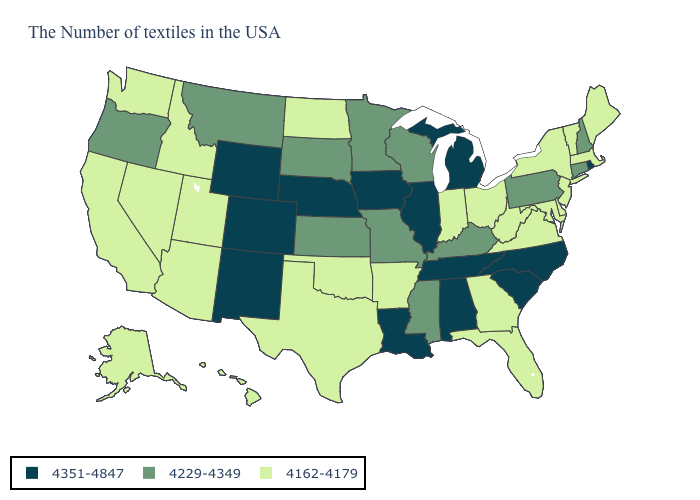Does Florida have the highest value in the South?
Be succinct. No. What is the value of Alaska?
Quick response, please. 4162-4179. Name the states that have a value in the range 4162-4179?
Keep it brief. Maine, Massachusetts, Vermont, New York, New Jersey, Delaware, Maryland, Virginia, West Virginia, Ohio, Florida, Georgia, Indiana, Arkansas, Oklahoma, Texas, North Dakota, Utah, Arizona, Idaho, Nevada, California, Washington, Alaska, Hawaii. Name the states that have a value in the range 4351-4847?
Give a very brief answer. Rhode Island, North Carolina, South Carolina, Michigan, Alabama, Tennessee, Illinois, Louisiana, Iowa, Nebraska, Wyoming, Colorado, New Mexico. Does Maryland have the lowest value in the South?
Short answer required. Yes. What is the value of New Jersey?
Write a very short answer. 4162-4179. Name the states that have a value in the range 4351-4847?
Give a very brief answer. Rhode Island, North Carolina, South Carolina, Michigan, Alabama, Tennessee, Illinois, Louisiana, Iowa, Nebraska, Wyoming, Colorado, New Mexico. Among the states that border Illinois , does Wisconsin have the lowest value?
Answer briefly. No. What is the highest value in the USA?
Be succinct. 4351-4847. What is the value of Ohio?
Write a very short answer. 4162-4179. What is the value of Connecticut?
Concise answer only. 4229-4349. Name the states that have a value in the range 4162-4179?
Short answer required. Maine, Massachusetts, Vermont, New York, New Jersey, Delaware, Maryland, Virginia, West Virginia, Ohio, Florida, Georgia, Indiana, Arkansas, Oklahoma, Texas, North Dakota, Utah, Arizona, Idaho, Nevada, California, Washington, Alaska, Hawaii. What is the highest value in the USA?
Write a very short answer. 4351-4847. Does the map have missing data?
Quick response, please. No. 